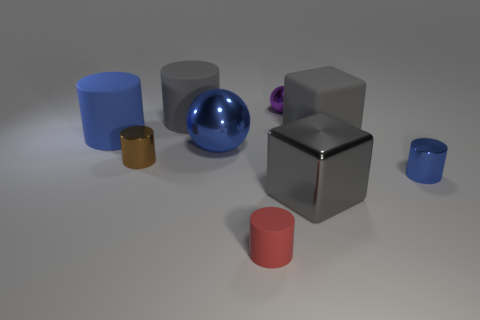Subtract all metal cylinders. How many cylinders are left? 3 Add 1 large red blocks. How many objects exist? 10 Subtract all purple spheres. How many spheres are left? 1 Subtract all cubes. How many objects are left? 7 Subtract 5 cylinders. How many cylinders are left? 0 Subtract all yellow cubes. Subtract all red balls. How many cubes are left? 2 Subtract all cyan spheres. How many red blocks are left? 0 Subtract all small rubber cylinders. Subtract all tiny yellow matte things. How many objects are left? 8 Add 5 rubber blocks. How many rubber blocks are left? 6 Add 5 big yellow metallic things. How many big yellow metallic things exist? 5 